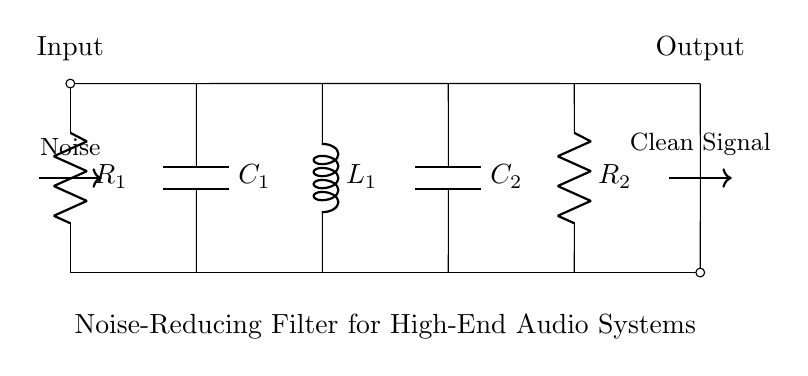What is the function of this circuit? The circuit is designed to reduce noise in high-end audio systems, enhancing sound quality by filtering out unwanted frequencies.
Answer: Noise-reducing filter How many resistors are in the circuit? The circuit contains two resistors, labeled as R1 and R2. Countable from the circuit diagram.
Answer: Two What components are used in this filter circuit? The circuit consists of two resistors, two capacitors, and one inductor. These elements work together to filter frequencies.
Answer: Two resistors, two capacitors, one inductor What is the output of this circuit? The output of the circuit is a clean audio signal, free from the noise that was present in the input. The signal flows from the output node.
Answer: Clean signal What type of filter is represented in this circuit? It is a passive filter, as it uses passive components (resistors, capacitors, and inductors) to reduce noise without amplification.
Answer: Passive filter Which component is directly connected to the input? The first component connected directly to the input is R1, which plays a role in the filtering process.
Answer: R1 How many total components are there in the circuit? There are five primary components in total: two resistors, two capacitors, and one inductor, which are essential for the filtering operation.
Answer: Five 